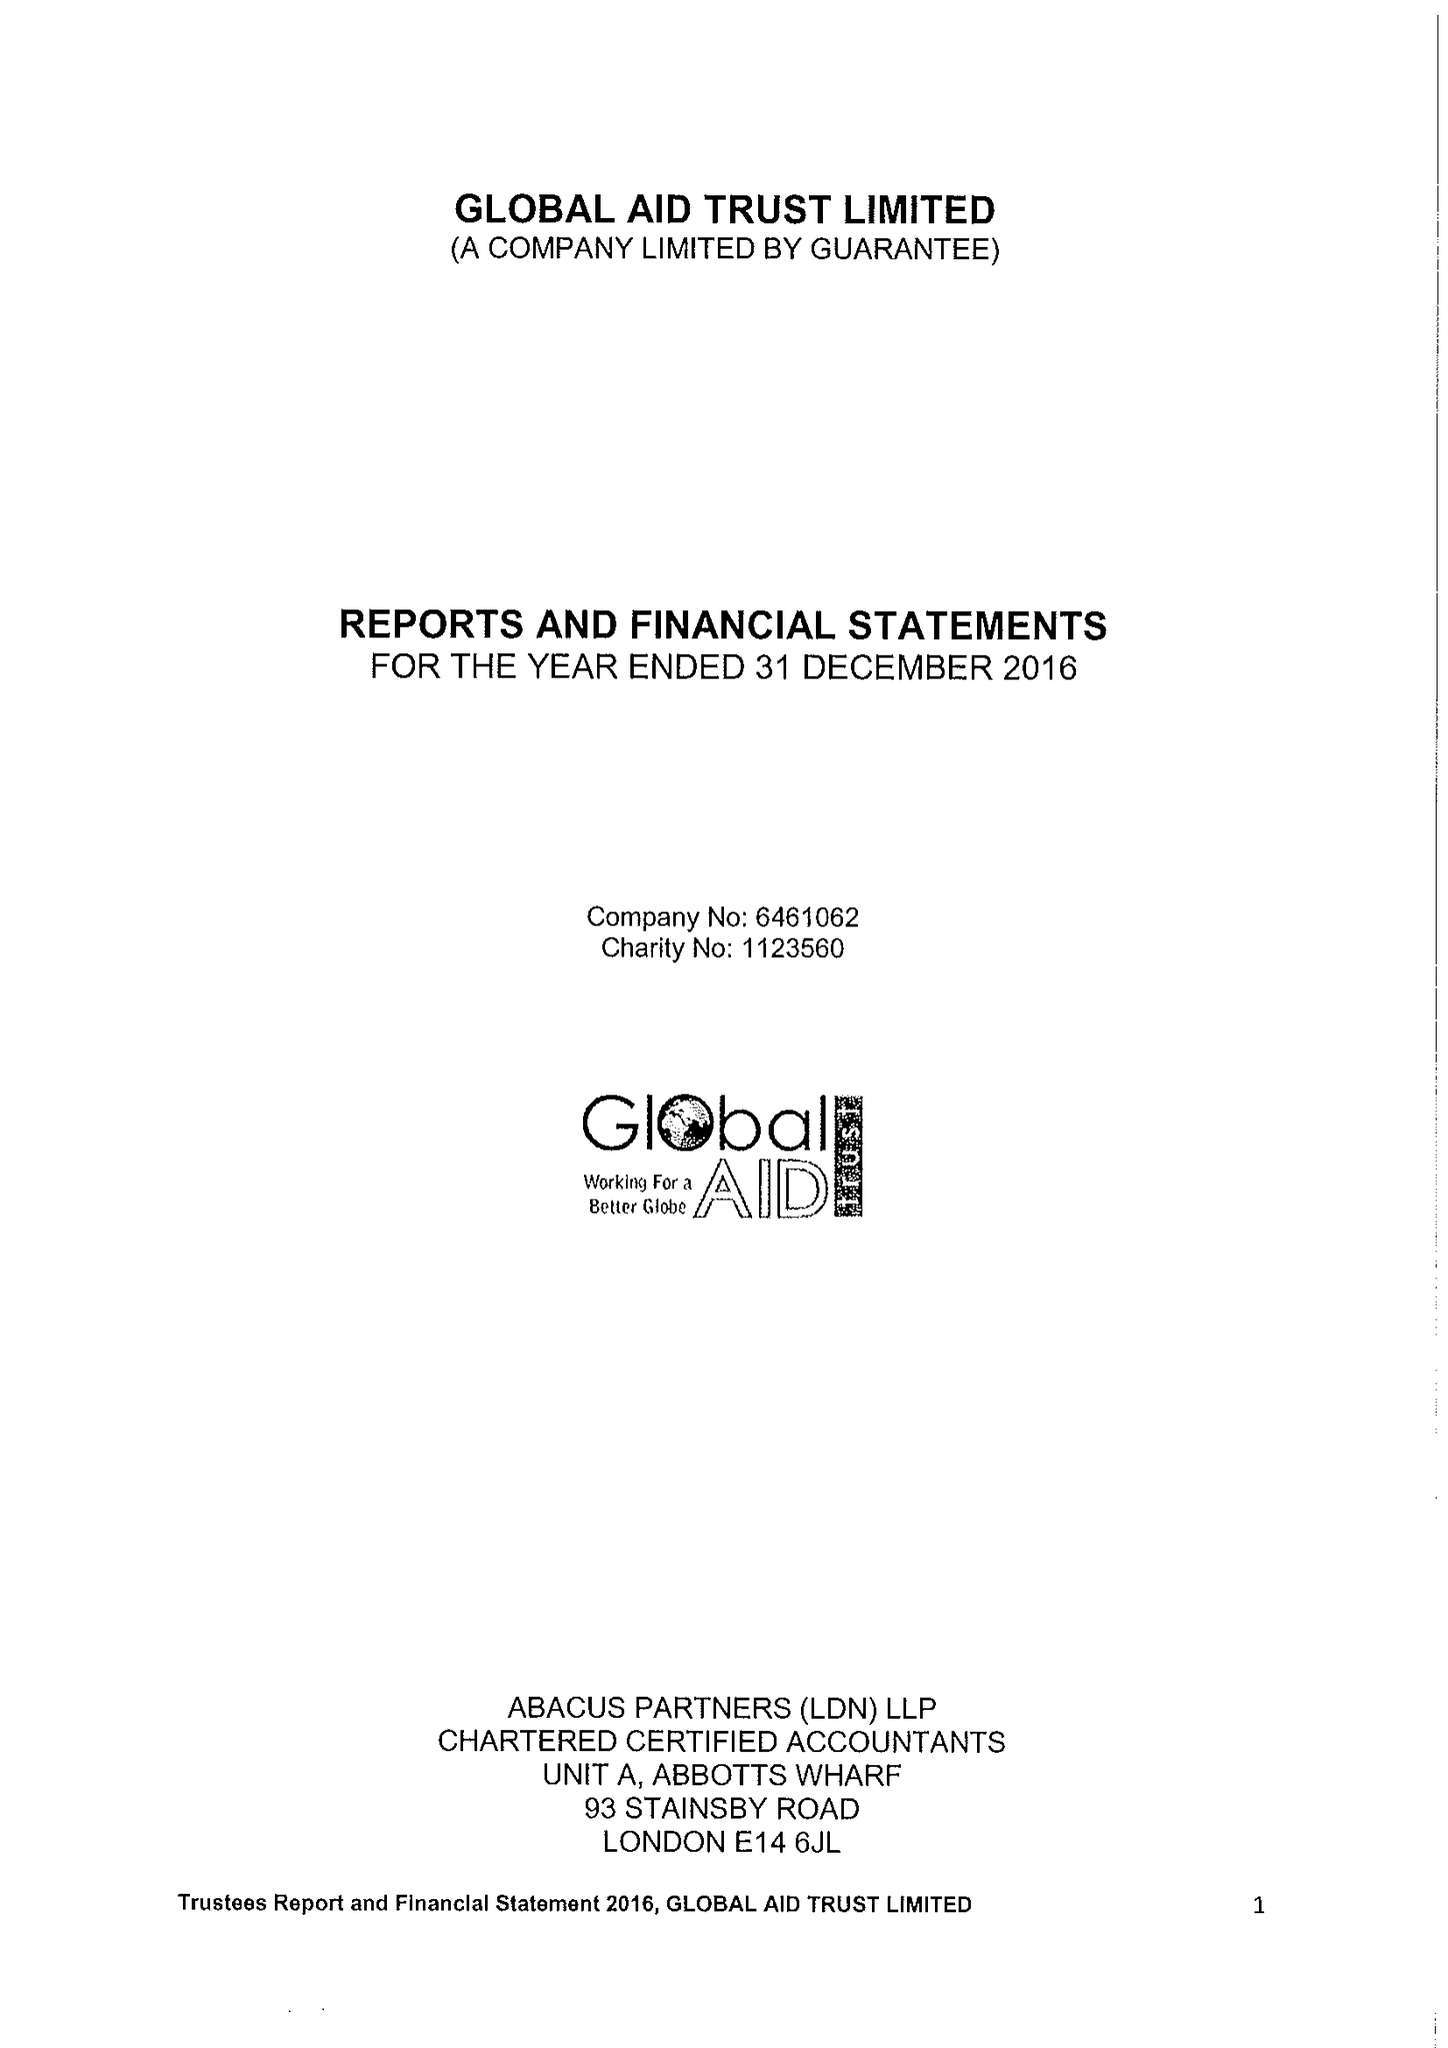What is the value for the income_annually_in_british_pounds?
Answer the question using a single word or phrase. 284761.00 